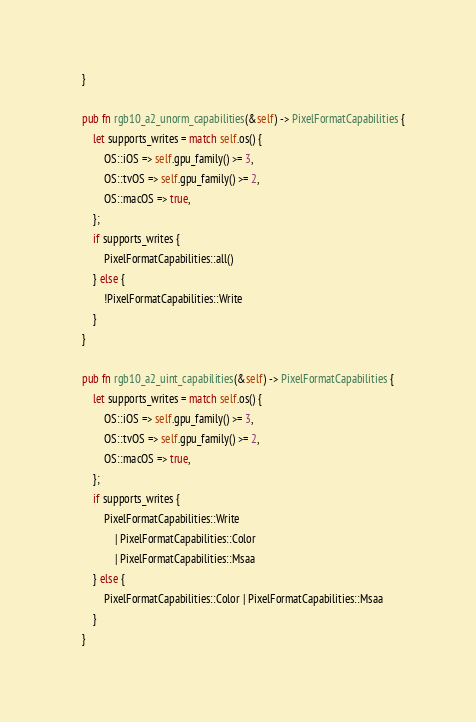<code> <loc_0><loc_0><loc_500><loc_500><_Rust_>    }

    pub fn rgb10_a2_unorm_capabilities(&self) -> PixelFormatCapabilities {
        let supports_writes = match self.os() {
            OS::iOS => self.gpu_family() >= 3,
            OS::tvOS => self.gpu_family() >= 2,
            OS::macOS => true,
        };
        if supports_writes {
            PixelFormatCapabilities::all()
        } else {
            !PixelFormatCapabilities::Write
        }
    }

    pub fn rgb10_a2_uint_capabilities(&self) -> PixelFormatCapabilities {
        let supports_writes = match self.os() {
            OS::iOS => self.gpu_family() >= 3,
            OS::tvOS => self.gpu_family() >= 2,
            OS::macOS => true,
        };
        if supports_writes {
            PixelFormatCapabilities::Write
                | PixelFormatCapabilities::Color
                | PixelFormatCapabilities::Msaa
        } else {
            PixelFormatCapabilities::Color | PixelFormatCapabilities::Msaa
        }
    }
</code> 